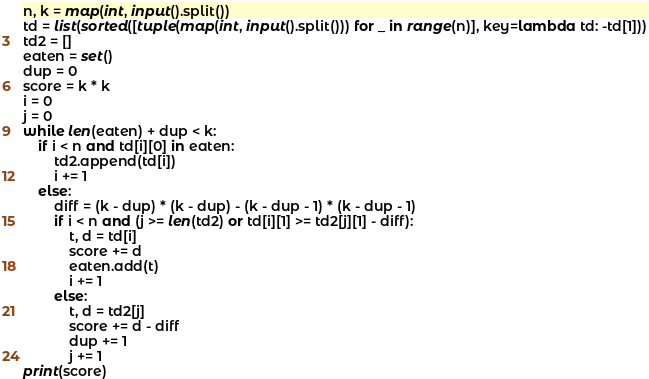Convert code to text. <code><loc_0><loc_0><loc_500><loc_500><_Python_>n, k = map(int, input().split())
td = list(sorted([tuple(map(int, input().split())) for _ in range(n)], key=lambda td: -td[1]))
td2 = []
eaten = set()
dup = 0
score = k * k
i = 0
j = 0
while len(eaten) + dup < k:
    if i < n and td[i][0] in eaten:
        td2.append(td[i])
        i += 1
    else:
        diff = (k - dup) * (k - dup) - (k - dup - 1) * (k - dup - 1)
        if i < n and (j >= len(td2) or td[i][1] >= td2[j][1] - diff):
            t, d = td[i]
            score += d
            eaten.add(t)
            i += 1
        else:
            t, d = td2[j]
            score += d - diff
            dup += 1
            j += 1
print(score)
</code> 